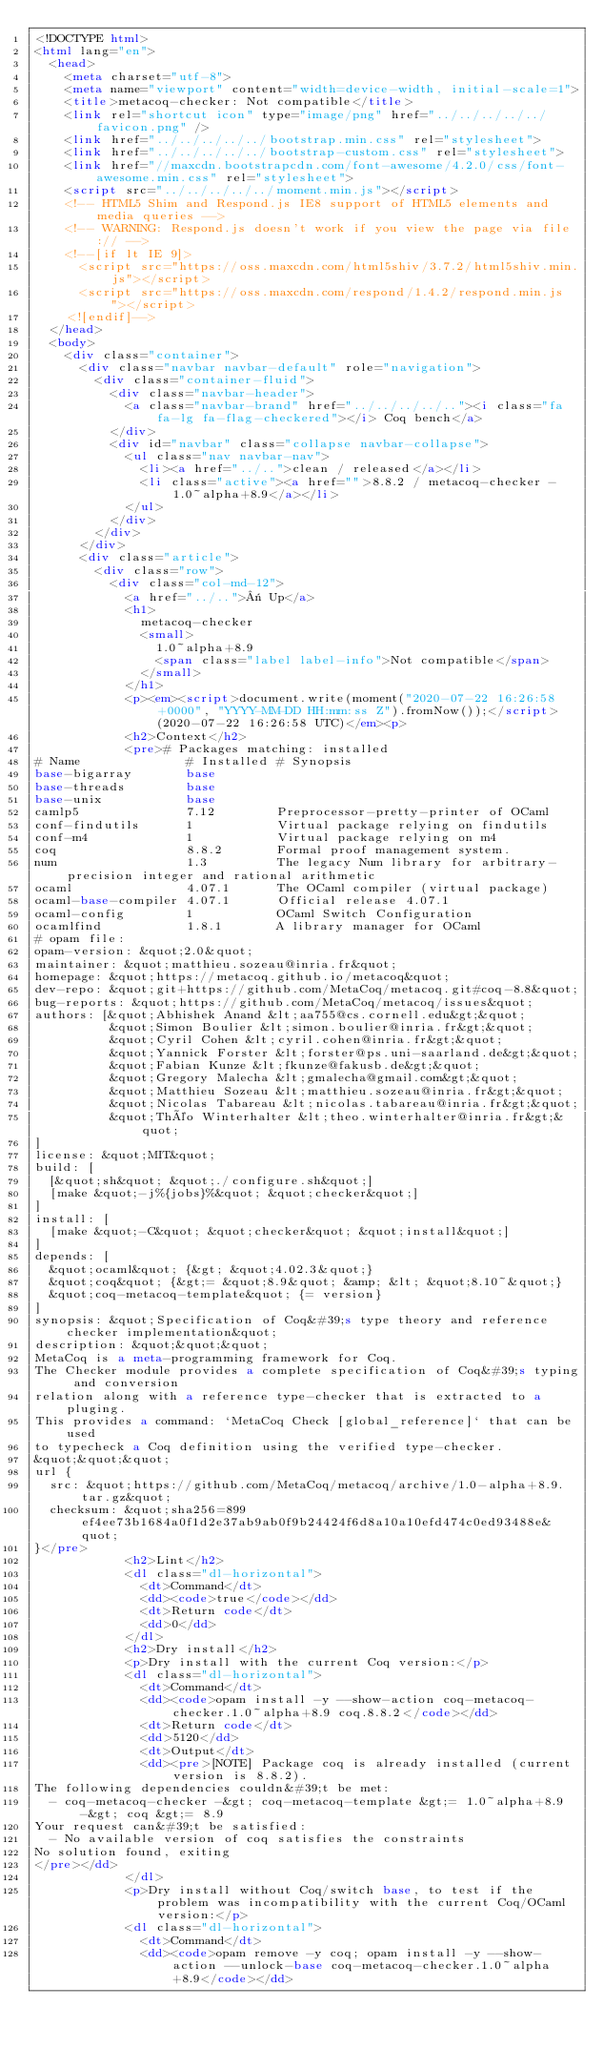<code> <loc_0><loc_0><loc_500><loc_500><_HTML_><!DOCTYPE html>
<html lang="en">
  <head>
    <meta charset="utf-8">
    <meta name="viewport" content="width=device-width, initial-scale=1">
    <title>metacoq-checker: Not compatible</title>
    <link rel="shortcut icon" type="image/png" href="../../../../../favicon.png" />
    <link href="../../../../../bootstrap.min.css" rel="stylesheet">
    <link href="../../../../../bootstrap-custom.css" rel="stylesheet">
    <link href="//maxcdn.bootstrapcdn.com/font-awesome/4.2.0/css/font-awesome.min.css" rel="stylesheet">
    <script src="../../../../../moment.min.js"></script>
    <!-- HTML5 Shim and Respond.js IE8 support of HTML5 elements and media queries -->
    <!-- WARNING: Respond.js doesn't work if you view the page via file:// -->
    <!--[if lt IE 9]>
      <script src="https://oss.maxcdn.com/html5shiv/3.7.2/html5shiv.min.js"></script>
      <script src="https://oss.maxcdn.com/respond/1.4.2/respond.min.js"></script>
    <![endif]-->
  </head>
  <body>
    <div class="container">
      <div class="navbar navbar-default" role="navigation">
        <div class="container-fluid">
          <div class="navbar-header">
            <a class="navbar-brand" href="../../../../.."><i class="fa fa-lg fa-flag-checkered"></i> Coq bench</a>
          </div>
          <div id="navbar" class="collapse navbar-collapse">
            <ul class="nav navbar-nav">
              <li><a href="../..">clean / released</a></li>
              <li class="active"><a href="">8.8.2 / metacoq-checker - 1.0~alpha+8.9</a></li>
            </ul>
          </div>
        </div>
      </div>
      <div class="article">
        <div class="row">
          <div class="col-md-12">
            <a href="../..">« Up</a>
            <h1>
              metacoq-checker
              <small>
                1.0~alpha+8.9
                <span class="label label-info">Not compatible</span>
              </small>
            </h1>
            <p><em><script>document.write(moment("2020-07-22 16:26:58 +0000", "YYYY-MM-DD HH:mm:ss Z").fromNow());</script> (2020-07-22 16:26:58 UTC)</em><p>
            <h2>Context</h2>
            <pre># Packages matching: installed
# Name              # Installed # Synopsis
base-bigarray       base
base-threads        base
base-unix           base
camlp5              7.12        Preprocessor-pretty-printer of OCaml
conf-findutils      1           Virtual package relying on findutils
conf-m4             1           Virtual package relying on m4
coq                 8.8.2       Formal proof management system.
num                 1.3         The legacy Num library for arbitrary-precision integer and rational arithmetic
ocaml               4.07.1      The OCaml compiler (virtual package)
ocaml-base-compiler 4.07.1      Official release 4.07.1
ocaml-config        1           OCaml Switch Configuration
ocamlfind           1.8.1       A library manager for OCaml
# opam file:
opam-version: &quot;2.0&quot;
maintainer: &quot;matthieu.sozeau@inria.fr&quot;
homepage: &quot;https://metacoq.github.io/metacoq&quot;
dev-repo: &quot;git+https://github.com/MetaCoq/metacoq.git#coq-8.8&quot;
bug-reports: &quot;https://github.com/MetaCoq/metacoq/issues&quot;
authors: [&quot;Abhishek Anand &lt;aa755@cs.cornell.edu&gt;&quot;
          &quot;Simon Boulier &lt;simon.boulier@inria.fr&gt;&quot;
          &quot;Cyril Cohen &lt;cyril.cohen@inria.fr&gt;&quot;
          &quot;Yannick Forster &lt;forster@ps.uni-saarland.de&gt;&quot;
          &quot;Fabian Kunze &lt;fkunze@fakusb.de&gt;&quot;
          &quot;Gregory Malecha &lt;gmalecha@gmail.com&gt;&quot;
          &quot;Matthieu Sozeau &lt;matthieu.sozeau@inria.fr&gt;&quot;
          &quot;Nicolas Tabareau &lt;nicolas.tabareau@inria.fr&gt;&quot;
          &quot;Théo Winterhalter &lt;theo.winterhalter@inria.fr&gt;&quot;
]
license: &quot;MIT&quot;
build: [
  [&quot;sh&quot; &quot;./configure.sh&quot;]
  [make &quot;-j%{jobs}%&quot; &quot;checker&quot;]
]
install: [
  [make &quot;-C&quot; &quot;checker&quot; &quot;install&quot;]
]
depends: [
  &quot;ocaml&quot; {&gt; &quot;4.02.3&quot;}
  &quot;coq&quot; {&gt;= &quot;8.9&quot; &amp; &lt; &quot;8.10~&quot;}
  &quot;coq-metacoq-template&quot; {= version}
]
synopsis: &quot;Specification of Coq&#39;s type theory and reference checker implementation&quot;
description: &quot;&quot;&quot;
MetaCoq is a meta-programming framework for Coq.
The Checker module provides a complete specification of Coq&#39;s typing and conversion
relation along with a reference type-checker that is extracted to a pluging.
This provides a command: `MetaCoq Check [global_reference]` that can be used
to typecheck a Coq definition using the verified type-checker.
&quot;&quot;&quot;
url {
  src: &quot;https://github.com/MetaCoq/metacoq/archive/1.0-alpha+8.9.tar.gz&quot;
  checksum: &quot;sha256=899ef4ee73b1684a0f1d2e37ab9ab0f9b24424f6d8a10a10efd474c0ed93488e&quot;
}</pre>
            <h2>Lint</h2>
            <dl class="dl-horizontal">
              <dt>Command</dt>
              <dd><code>true</code></dd>
              <dt>Return code</dt>
              <dd>0</dd>
            </dl>
            <h2>Dry install</h2>
            <p>Dry install with the current Coq version:</p>
            <dl class="dl-horizontal">
              <dt>Command</dt>
              <dd><code>opam install -y --show-action coq-metacoq-checker.1.0~alpha+8.9 coq.8.8.2</code></dd>
              <dt>Return code</dt>
              <dd>5120</dd>
              <dt>Output</dt>
              <dd><pre>[NOTE] Package coq is already installed (current version is 8.8.2).
The following dependencies couldn&#39;t be met:
  - coq-metacoq-checker -&gt; coq-metacoq-template &gt;= 1.0~alpha+8.9 -&gt; coq &gt;= 8.9
Your request can&#39;t be satisfied:
  - No available version of coq satisfies the constraints
No solution found, exiting
</pre></dd>
            </dl>
            <p>Dry install without Coq/switch base, to test if the problem was incompatibility with the current Coq/OCaml version:</p>
            <dl class="dl-horizontal">
              <dt>Command</dt>
              <dd><code>opam remove -y coq; opam install -y --show-action --unlock-base coq-metacoq-checker.1.0~alpha+8.9</code></dd></code> 